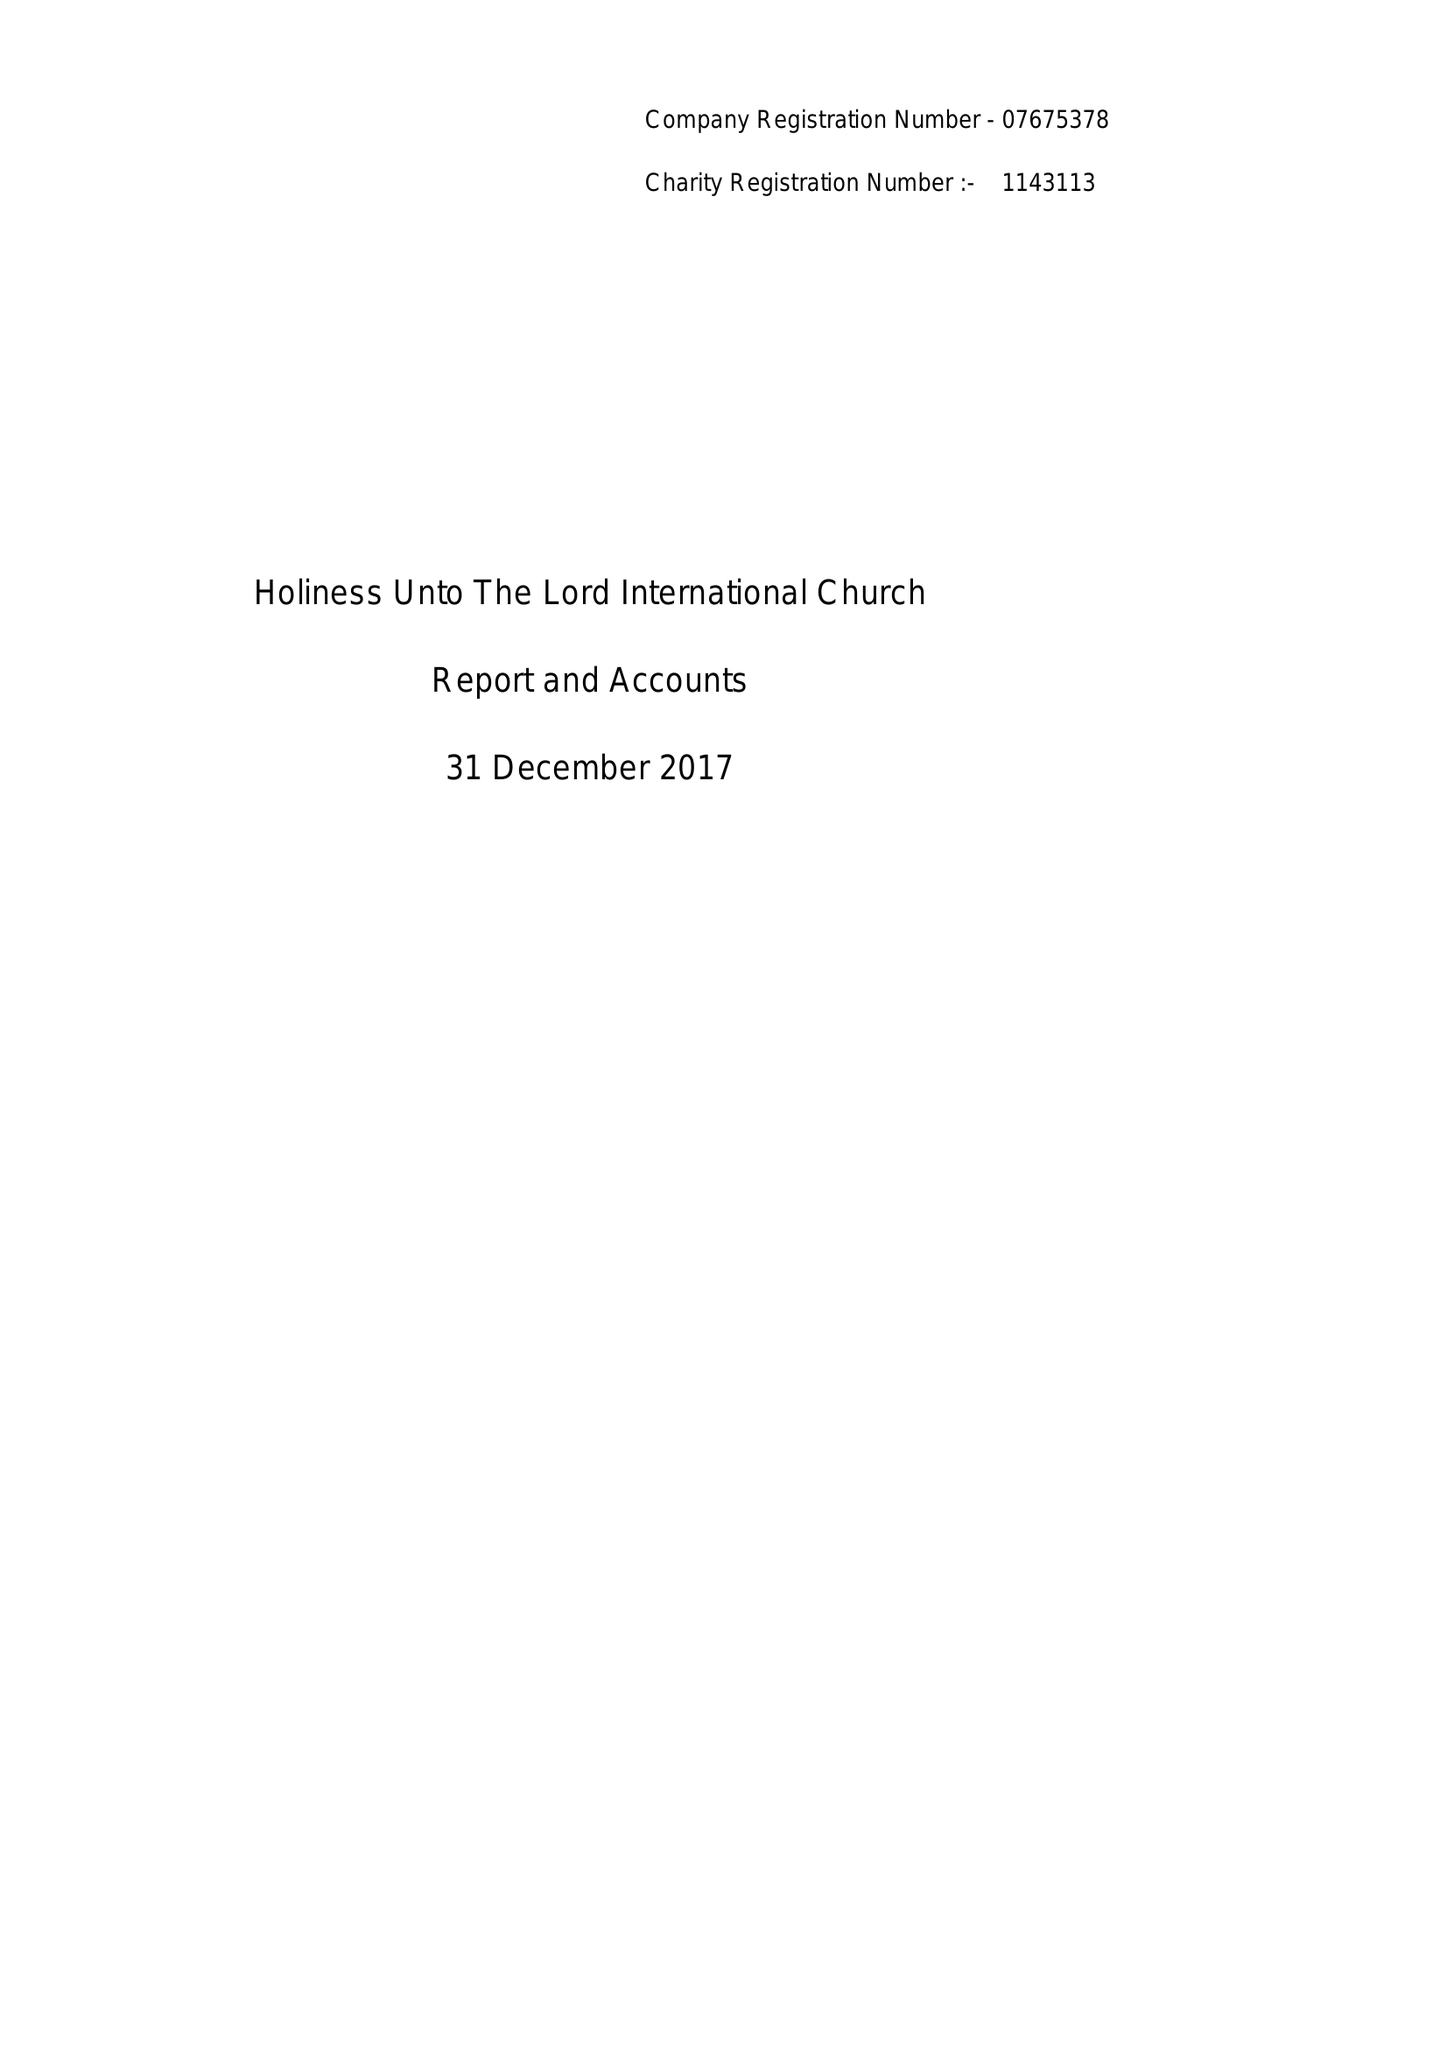What is the value for the charity_name?
Answer the question using a single word or phrase. Holiness Unto The Lord International Church 